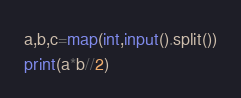<code> <loc_0><loc_0><loc_500><loc_500><_Python_>a,b,c=map(int,input().split())
print(a*b//2)</code> 